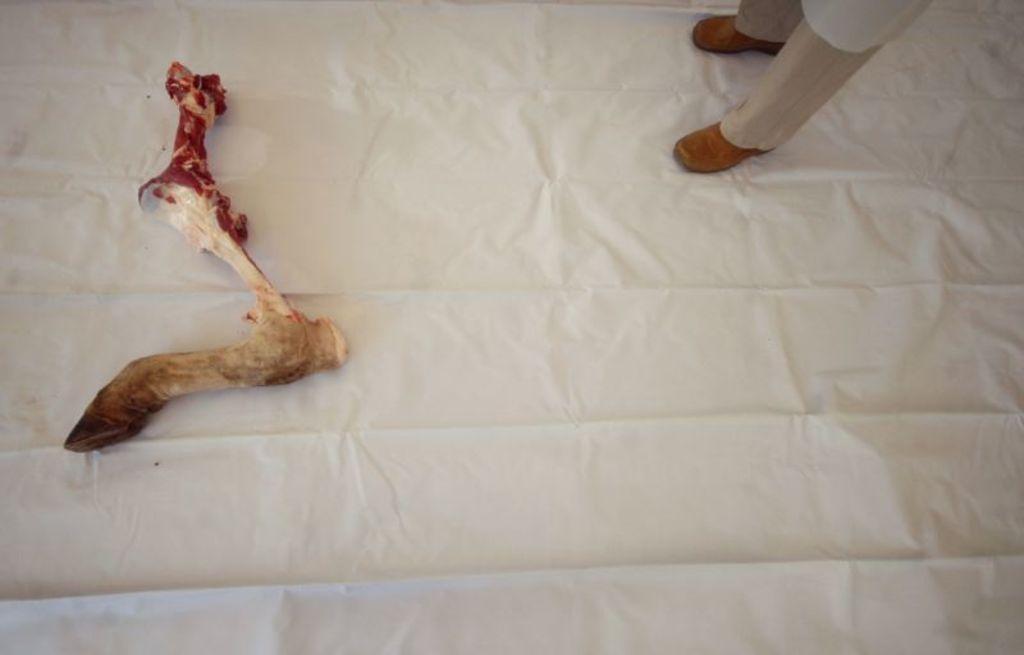Please provide a concise description of this image. In this image we can see some persons legs with shoes and we can also see a bone on the white color cloth. 